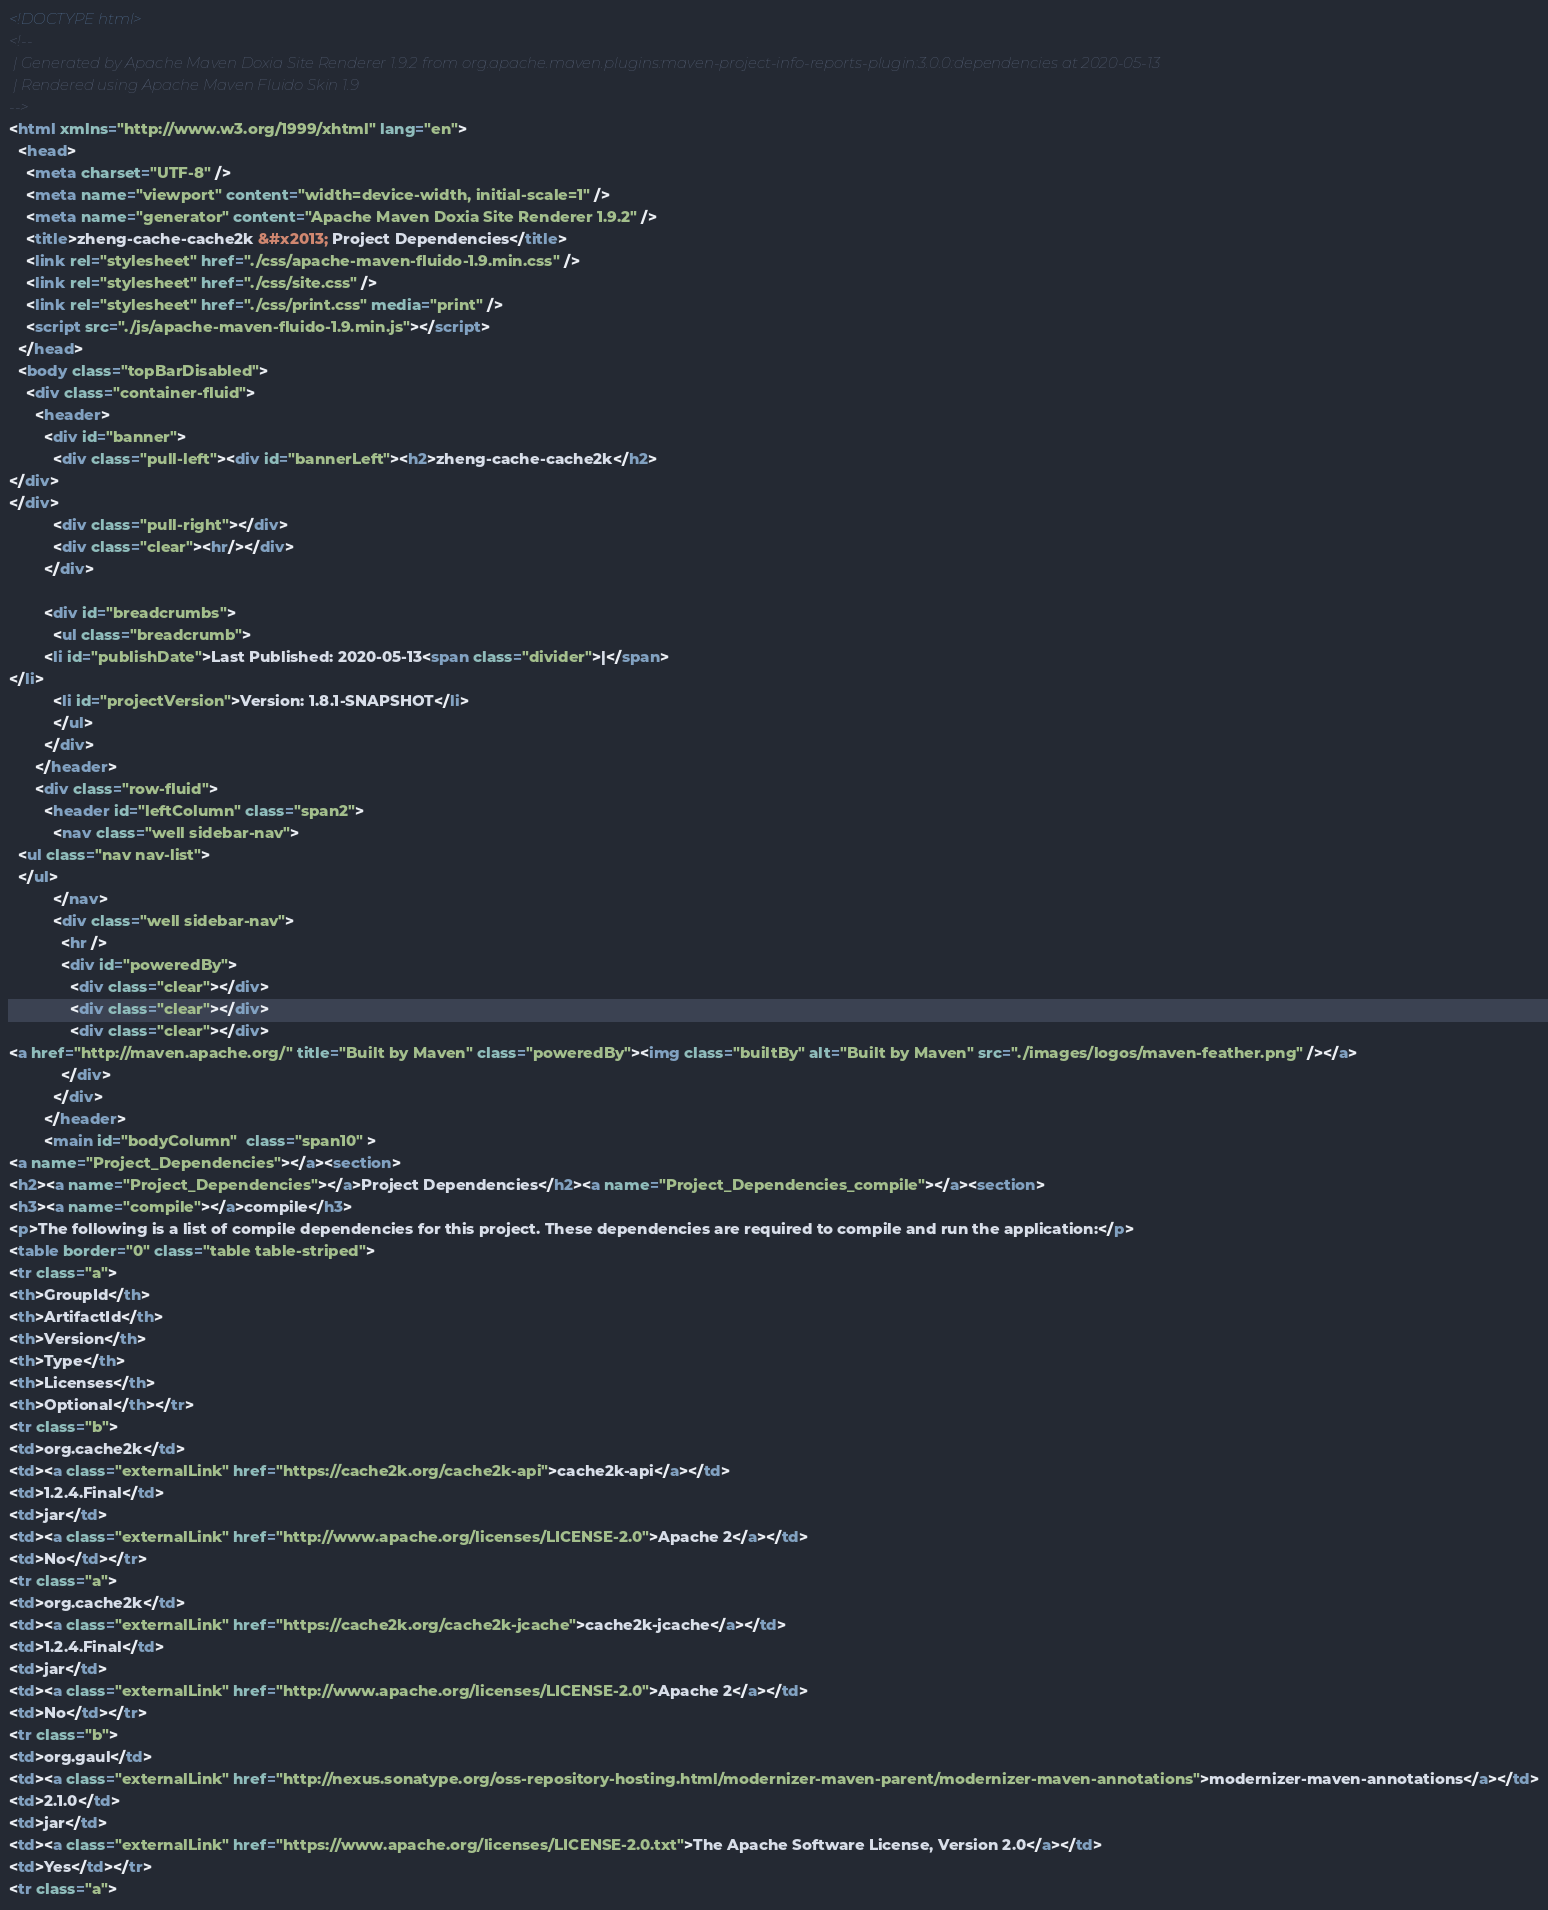Convert code to text. <code><loc_0><loc_0><loc_500><loc_500><_HTML_><!DOCTYPE html>
<!--
 | Generated by Apache Maven Doxia Site Renderer 1.9.2 from org.apache.maven.plugins:maven-project-info-reports-plugin:3.0.0:dependencies at 2020-05-13
 | Rendered using Apache Maven Fluido Skin 1.9
-->
<html xmlns="http://www.w3.org/1999/xhtml" lang="en">
  <head>
    <meta charset="UTF-8" />
    <meta name="viewport" content="width=device-width, initial-scale=1" />
    <meta name="generator" content="Apache Maven Doxia Site Renderer 1.9.2" />
    <title>zheng-cache-cache2k &#x2013; Project Dependencies</title>
    <link rel="stylesheet" href="./css/apache-maven-fluido-1.9.min.css" />
    <link rel="stylesheet" href="./css/site.css" />
    <link rel="stylesheet" href="./css/print.css" media="print" />
    <script src="./js/apache-maven-fluido-1.9.min.js"></script>
  </head>
  <body class="topBarDisabled">
    <div class="container-fluid">
      <header>
        <div id="banner">
          <div class="pull-left"><div id="bannerLeft"><h2>zheng-cache-cache2k</h2>
</div>
</div>
          <div class="pull-right"></div>
          <div class="clear"><hr/></div>
        </div>

        <div id="breadcrumbs">
          <ul class="breadcrumb">
        <li id="publishDate">Last Published: 2020-05-13<span class="divider">|</span>
</li>
          <li id="projectVersion">Version: 1.8.1-SNAPSHOT</li>
          </ul>
        </div>
      </header>
      <div class="row-fluid">
        <header id="leftColumn" class="span2">
          <nav class="well sidebar-nav">
  <ul class="nav nav-list">
  </ul>
          </nav>
          <div class="well sidebar-nav">
            <hr />
            <div id="poweredBy">
              <div class="clear"></div>
              <div class="clear"></div>
              <div class="clear"></div>
<a href="http://maven.apache.org/" title="Built by Maven" class="poweredBy"><img class="builtBy" alt="Built by Maven" src="./images/logos/maven-feather.png" /></a>
            </div>
          </div>
        </header>
        <main id="bodyColumn"  class="span10" >
<a name="Project_Dependencies"></a><section>
<h2><a name="Project_Dependencies"></a>Project Dependencies</h2><a name="Project_Dependencies_compile"></a><section>
<h3><a name="compile"></a>compile</h3>
<p>The following is a list of compile dependencies for this project. These dependencies are required to compile and run the application:</p>
<table border="0" class="table table-striped">
<tr class="a">
<th>GroupId</th>
<th>ArtifactId</th>
<th>Version</th>
<th>Type</th>
<th>Licenses</th>
<th>Optional</th></tr>
<tr class="b">
<td>org.cache2k</td>
<td><a class="externalLink" href="https://cache2k.org/cache2k-api">cache2k-api</a></td>
<td>1.2.4.Final</td>
<td>jar</td>
<td><a class="externalLink" href="http://www.apache.org/licenses/LICENSE-2.0">Apache 2</a></td>
<td>No</td></tr>
<tr class="a">
<td>org.cache2k</td>
<td><a class="externalLink" href="https://cache2k.org/cache2k-jcache">cache2k-jcache</a></td>
<td>1.2.4.Final</td>
<td>jar</td>
<td><a class="externalLink" href="http://www.apache.org/licenses/LICENSE-2.0">Apache 2</a></td>
<td>No</td></tr>
<tr class="b">
<td>org.gaul</td>
<td><a class="externalLink" href="http://nexus.sonatype.org/oss-repository-hosting.html/modernizer-maven-parent/modernizer-maven-annotations">modernizer-maven-annotations</a></td>
<td>2.1.0</td>
<td>jar</td>
<td><a class="externalLink" href="https://www.apache.org/licenses/LICENSE-2.0.txt">The Apache Software License, Version 2.0</a></td>
<td>Yes</td></tr>
<tr class="a"></code> 